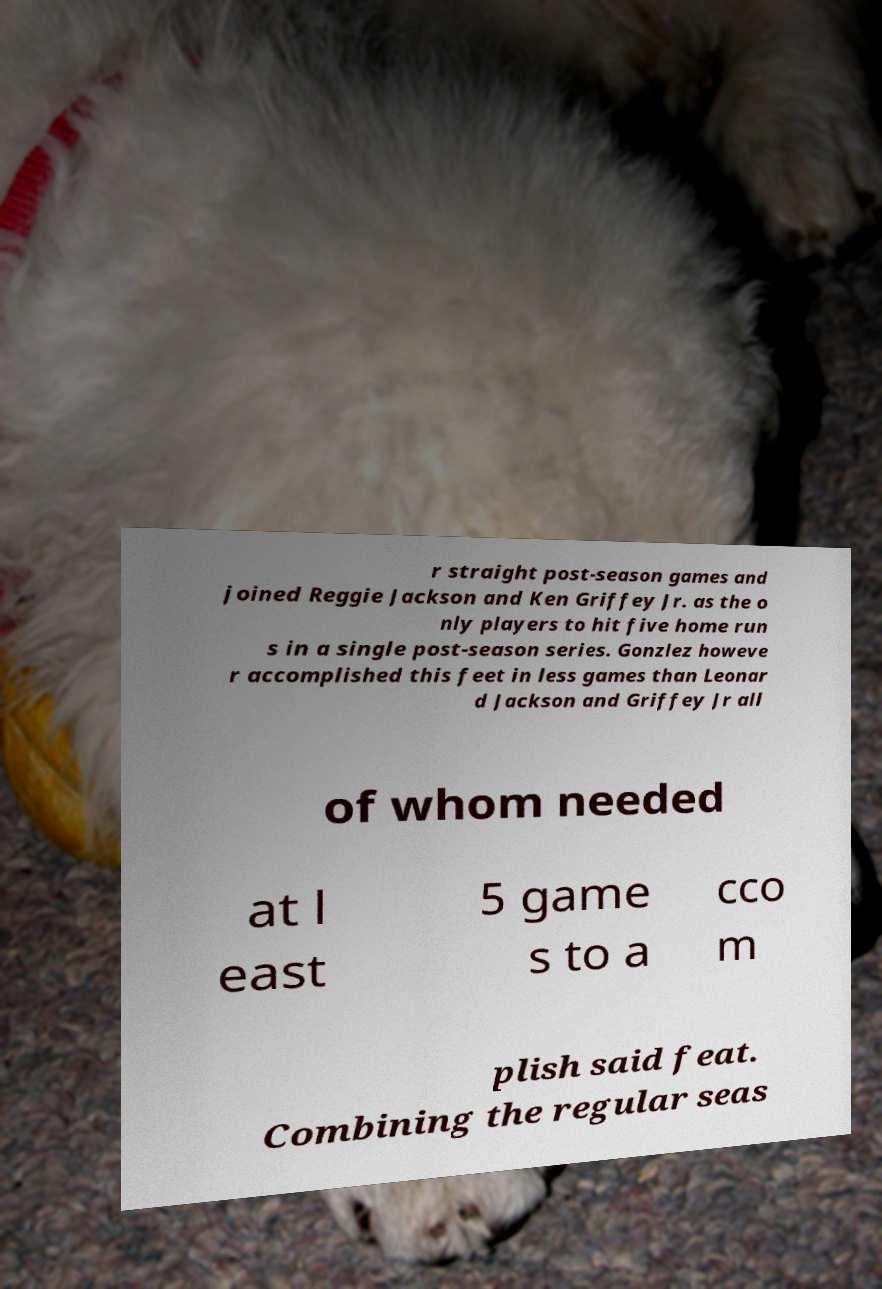Can you accurately transcribe the text from the provided image for me? r straight post-season games and joined Reggie Jackson and Ken Griffey Jr. as the o nly players to hit five home run s in a single post-season series. Gonzlez howeve r accomplished this feet in less games than Leonar d Jackson and Griffey Jr all of whom needed at l east 5 game s to a cco m plish said feat. Combining the regular seas 